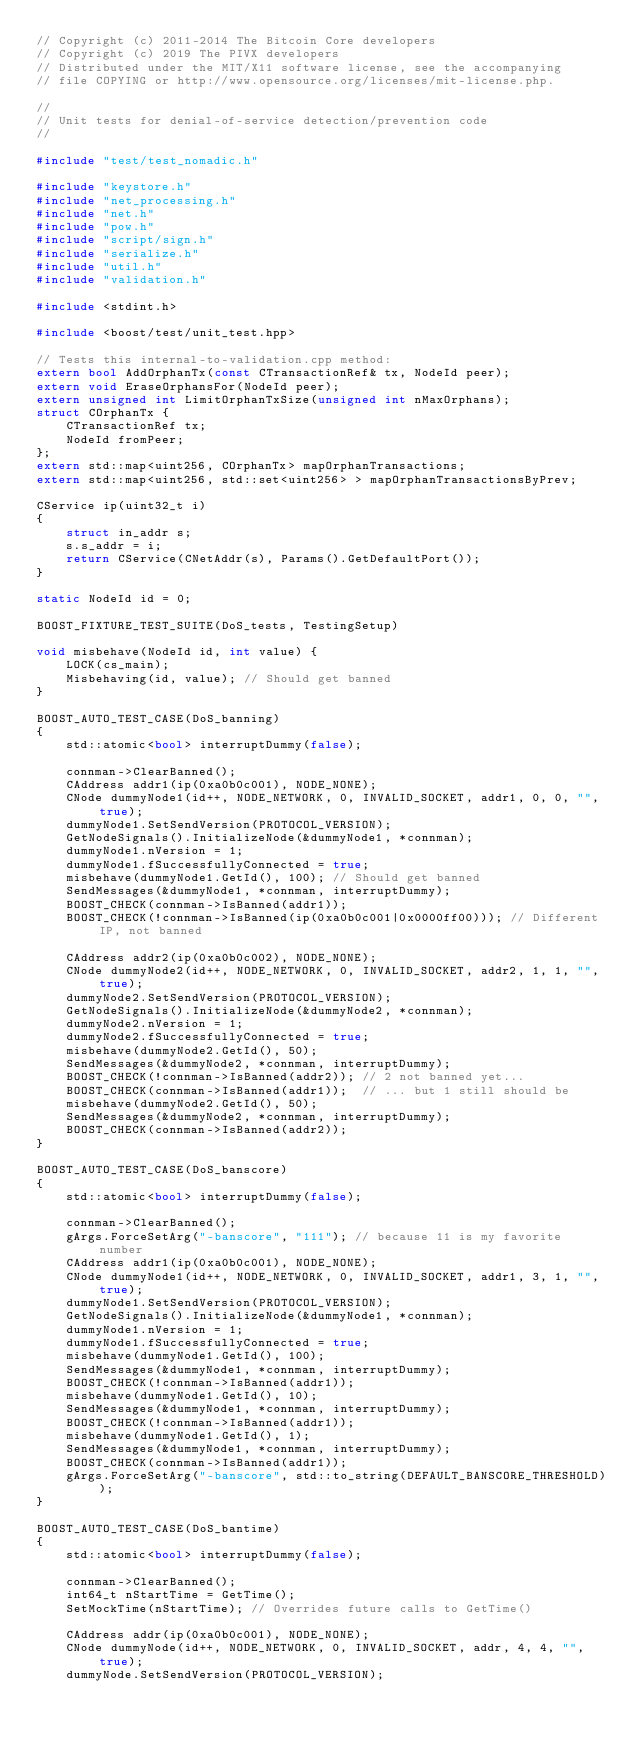<code> <loc_0><loc_0><loc_500><loc_500><_C++_>// Copyright (c) 2011-2014 The Bitcoin Core developers
// Copyright (c) 2019 The PIVX developers
// Distributed under the MIT/X11 software license, see the accompanying
// file COPYING or http://www.opensource.org/licenses/mit-license.php.

//
// Unit tests for denial-of-service detection/prevention code
//

#include "test/test_nomadic.h"

#include "keystore.h"
#include "net_processing.h"
#include "net.h"
#include "pow.h"
#include "script/sign.h"
#include "serialize.h"
#include "util.h"
#include "validation.h"

#include <stdint.h>

#include <boost/test/unit_test.hpp>

// Tests this internal-to-validation.cpp method:
extern bool AddOrphanTx(const CTransactionRef& tx, NodeId peer);
extern void EraseOrphansFor(NodeId peer);
extern unsigned int LimitOrphanTxSize(unsigned int nMaxOrphans);
struct COrphanTx {
    CTransactionRef tx;
    NodeId fromPeer;
};
extern std::map<uint256, COrphanTx> mapOrphanTransactions;
extern std::map<uint256, std::set<uint256> > mapOrphanTransactionsByPrev;

CService ip(uint32_t i)
{
    struct in_addr s;
    s.s_addr = i;
    return CService(CNetAddr(s), Params().GetDefaultPort());
}

static NodeId id = 0;

BOOST_FIXTURE_TEST_SUITE(DoS_tests, TestingSetup)

void misbehave(NodeId id, int value) {
    LOCK(cs_main);
    Misbehaving(id, value); // Should get banned
}

BOOST_AUTO_TEST_CASE(DoS_banning)
{
    std::atomic<bool> interruptDummy(false);

    connman->ClearBanned();
    CAddress addr1(ip(0xa0b0c001), NODE_NONE);
    CNode dummyNode1(id++, NODE_NETWORK, 0, INVALID_SOCKET, addr1, 0, 0, "", true);
    dummyNode1.SetSendVersion(PROTOCOL_VERSION);
    GetNodeSignals().InitializeNode(&dummyNode1, *connman);
    dummyNode1.nVersion = 1;
    dummyNode1.fSuccessfullyConnected = true;
    misbehave(dummyNode1.GetId(), 100); // Should get banned
    SendMessages(&dummyNode1, *connman, interruptDummy);
    BOOST_CHECK(connman->IsBanned(addr1));
    BOOST_CHECK(!connman->IsBanned(ip(0xa0b0c001|0x0000ff00))); // Different IP, not banned

    CAddress addr2(ip(0xa0b0c002), NODE_NONE);
    CNode dummyNode2(id++, NODE_NETWORK, 0, INVALID_SOCKET, addr2, 1, 1, "", true);
    dummyNode2.SetSendVersion(PROTOCOL_VERSION);
    GetNodeSignals().InitializeNode(&dummyNode2, *connman);
    dummyNode2.nVersion = 1;
    dummyNode2.fSuccessfullyConnected = true;
    misbehave(dummyNode2.GetId(), 50);
    SendMessages(&dummyNode2, *connman, interruptDummy);
    BOOST_CHECK(!connman->IsBanned(addr2)); // 2 not banned yet...
    BOOST_CHECK(connman->IsBanned(addr1));  // ... but 1 still should be
    misbehave(dummyNode2.GetId(), 50);
    SendMessages(&dummyNode2, *connman, interruptDummy);
    BOOST_CHECK(connman->IsBanned(addr2));
}

BOOST_AUTO_TEST_CASE(DoS_banscore)
{
    std::atomic<bool> interruptDummy(false);

    connman->ClearBanned();
    gArgs.ForceSetArg("-banscore", "111"); // because 11 is my favorite number
    CAddress addr1(ip(0xa0b0c001), NODE_NONE);
    CNode dummyNode1(id++, NODE_NETWORK, 0, INVALID_SOCKET, addr1, 3, 1, "", true);
    dummyNode1.SetSendVersion(PROTOCOL_VERSION);
    GetNodeSignals().InitializeNode(&dummyNode1, *connman);
    dummyNode1.nVersion = 1;
    dummyNode1.fSuccessfullyConnected = true;
    misbehave(dummyNode1.GetId(), 100);
    SendMessages(&dummyNode1, *connman, interruptDummy);
    BOOST_CHECK(!connman->IsBanned(addr1));
    misbehave(dummyNode1.GetId(), 10);
    SendMessages(&dummyNode1, *connman, interruptDummy);
    BOOST_CHECK(!connman->IsBanned(addr1));
    misbehave(dummyNode1.GetId(), 1);
    SendMessages(&dummyNode1, *connman, interruptDummy);
    BOOST_CHECK(connman->IsBanned(addr1));
    gArgs.ForceSetArg("-banscore", std::to_string(DEFAULT_BANSCORE_THRESHOLD));
}

BOOST_AUTO_TEST_CASE(DoS_bantime)
{
    std::atomic<bool> interruptDummy(false);

    connman->ClearBanned();
    int64_t nStartTime = GetTime();
    SetMockTime(nStartTime); // Overrides future calls to GetTime()

    CAddress addr(ip(0xa0b0c001), NODE_NONE);
    CNode dummyNode(id++, NODE_NETWORK, 0, INVALID_SOCKET, addr, 4, 4, "", true);
    dummyNode.SetSendVersion(PROTOCOL_VERSION);</code> 